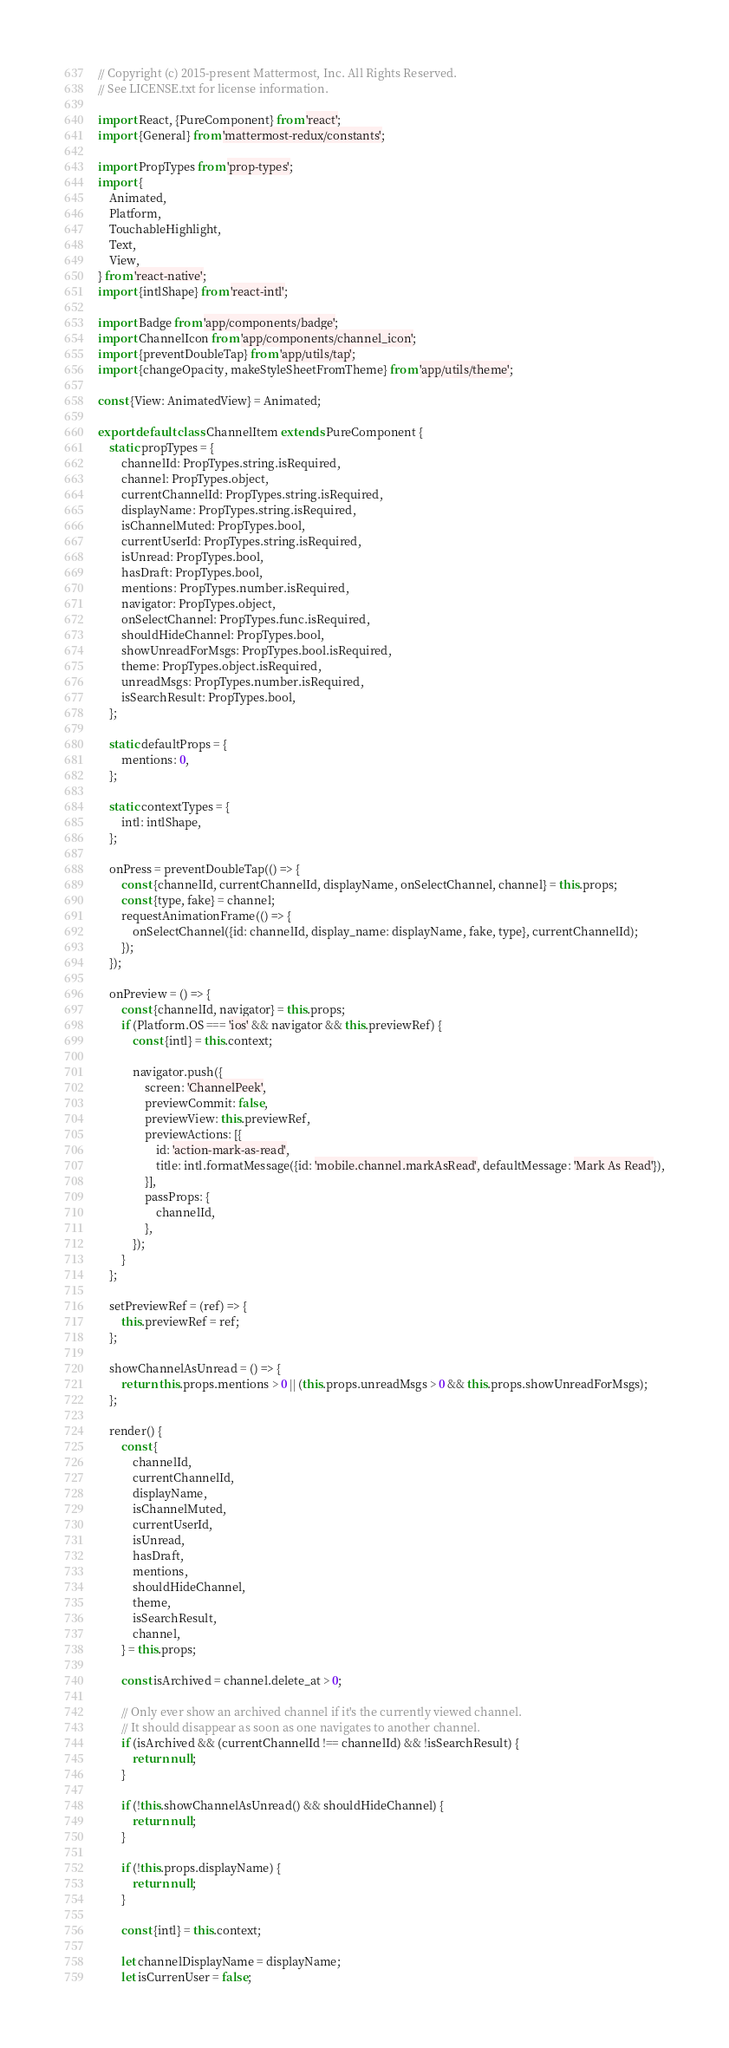Convert code to text. <code><loc_0><loc_0><loc_500><loc_500><_JavaScript_>// Copyright (c) 2015-present Mattermost, Inc. All Rights Reserved.
// See LICENSE.txt for license information.

import React, {PureComponent} from 'react';
import {General} from 'mattermost-redux/constants';

import PropTypes from 'prop-types';
import {
    Animated,
    Platform,
    TouchableHighlight,
    Text,
    View,
} from 'react-native';
import {intlShape} from 'react-intl';

import Badge from 'app/components/badge';
import ChannelIcon from 'app/components/channel_icon';
import {preventDoubleTap} from 'app/utils/tap';
import {changeOpacity, makeStyleSheetFromTheme} from 'app/utils/theme';

const {View: AnimatedView} = Animated;

export default class ChannelItem extends PureComponent {
    static propTypes = {
        channelId: PropTypes.string.isRequired,
        channel: PropTypes.object,
        currentChannelId: PropTypes.string.isRequired,
        displayName: PropTypes.string.isRequired,
        isChannelMuted: PropTypes.bool,
        currentUserId: PropTypes.string.isRequired,
        isUnread: PropTypes.bool,
        hasDraft: PropTypes.bool,
        mentions: PropTypes.number.isRequired,
        navigator: PropTypes.object,
        onSelectChannel: PropTypes.func.isRequired,
        shouldHideChannel: PropTypes.bool,
        showUnreadForMsgs: PropTypes.bool.isRequired,
        theme: PropTypes.object.isRequired,
        unreadMsgs: PropTypes.number.isRequired,
        isSearchResult: PropTypes.bool,
    };

    static defaultProps = {
        mentions: 0,
    };

    static contextTypes = {
        intl: intlShape,
    };

    onPress = preventDoubleTap(() => {
        const {channelId, currentChannelId, displayName, onSelectChannel, channel} = this.props;
        const {type, fake} = channel;
        requestAnimationFrame(() => {
            onSelectChannel({id: channelId, display_name: displayName, fake, type}, currentChannelId);
        });
    });

    onPreview = () => {
        const {channelId, navigator} = this.props;
        if (Platform.OS === 'ios' && navigator && this.previewRef) {
            const {intl} = this.context;

            navigator.push({
                screen: 'ChannelPeek',
                previewCommit: false,
                previewView: this.previewRef,
                previewActions: [{
                    id: 'action-mark-as-read',
                    title: intl.formatMessage({id: 'mobile.channel.markAsRead', defaultMessage: 'Mark As Read'}),
                }],
                passProps: {
                    channelId,
                },
            });
        }
    };

    setPreviewRef = (ref) => {
        this.previewRef = ref;
    };

    showChannelAsUnread = () => {
        return this.props.mentions > 0 || (this.props.unreadMsgs > 0 && this.props.showUnreadForMsgs);
    };

    render() {
        const {
            channelId,
            currentChannelId,
            displayName,
            isChannelMuted,
            currentUserId,
            isUnread,
            hasDraft,
            mentions,
            shouldHideChannel,
            theme,
            isSearchResult,
            channel,
        } = this.props;

        const isArchived = channel.delete_at > 0;

        // Only ever show an archived channel if it's the currently viewed channel.
        // It should disappear as soon as one navigates to another channel.
        if (isArchived && (currentChannelId !== channelId) && !isSearchResult) {
            return null;
        }

        if (!this.showChannelAsUnread() && shouldHideChannel) {
            return null;
        }

        if (!this.props.displayName) {
            return null;
        }

        const {intl} = this.context;

        let channelDisplayName = displayName;
        let isCurrenUser = false;
</code> 